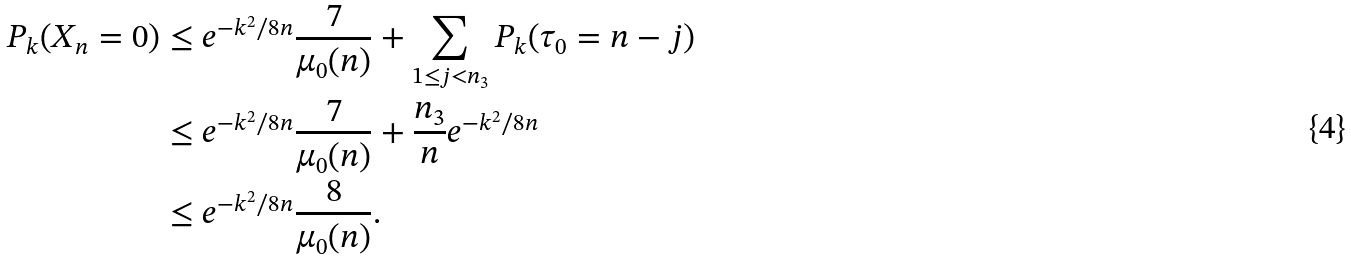Convert formula to latex. <formula><loc_0><loc_0><loc_500><loc_500>P _ { k } ( X _ { n } = 0 ) & \leq e ^ { - k ^ { 2 } / 8 n } \frac { 7 } { \mu _ { 0 } ( n ) } + \sum _ { 1 \leq j < n _ { 3 } } P _ { k } ( \tau _ { 0 } = n - j ) \\ & \leq e ^ { - k ^ { 2 } / 8 n } \frac { 7 } { \mu _ { 0 } ( n ) } + \frac { n _ { 3 } } { n } e ^ { - k ^ { 2 } / 8 n } \\ & \leq e ^ { - k ^ { 2 } / 8 n } \frac { 8 } { \mu _ { 0 } ( n ) } .</formula> 